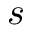Convert formula to latex. <formula><loc_0><loc_0><loc_500><loc_500>s</formula> 